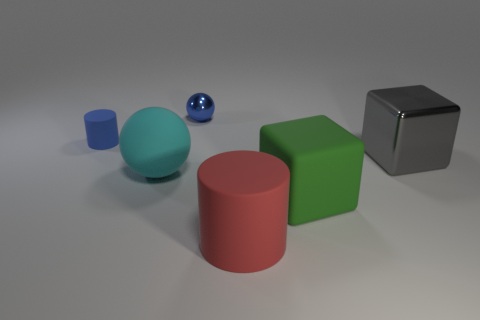Add 2 yellow things. How many objects exist? 8 Subtract all blue balls. How many balls are left? 1 Subtract 1 spheres. How many spheres are left? 1 Subtract all cyan cylinders. Subtract all purple cubes. How many cylinders are left? 2 Subtract all cubes. How many objects are left? 4 Subtract all large red matte objects. Subtract all cylinders. How many objects are left? 3 Add 5 small blue things. How many small blue things are left? 7 Add 1 big green blocks. How many big green blocks exist? 2 Subtract 0 cyan blocks. How many objects are left? 6 